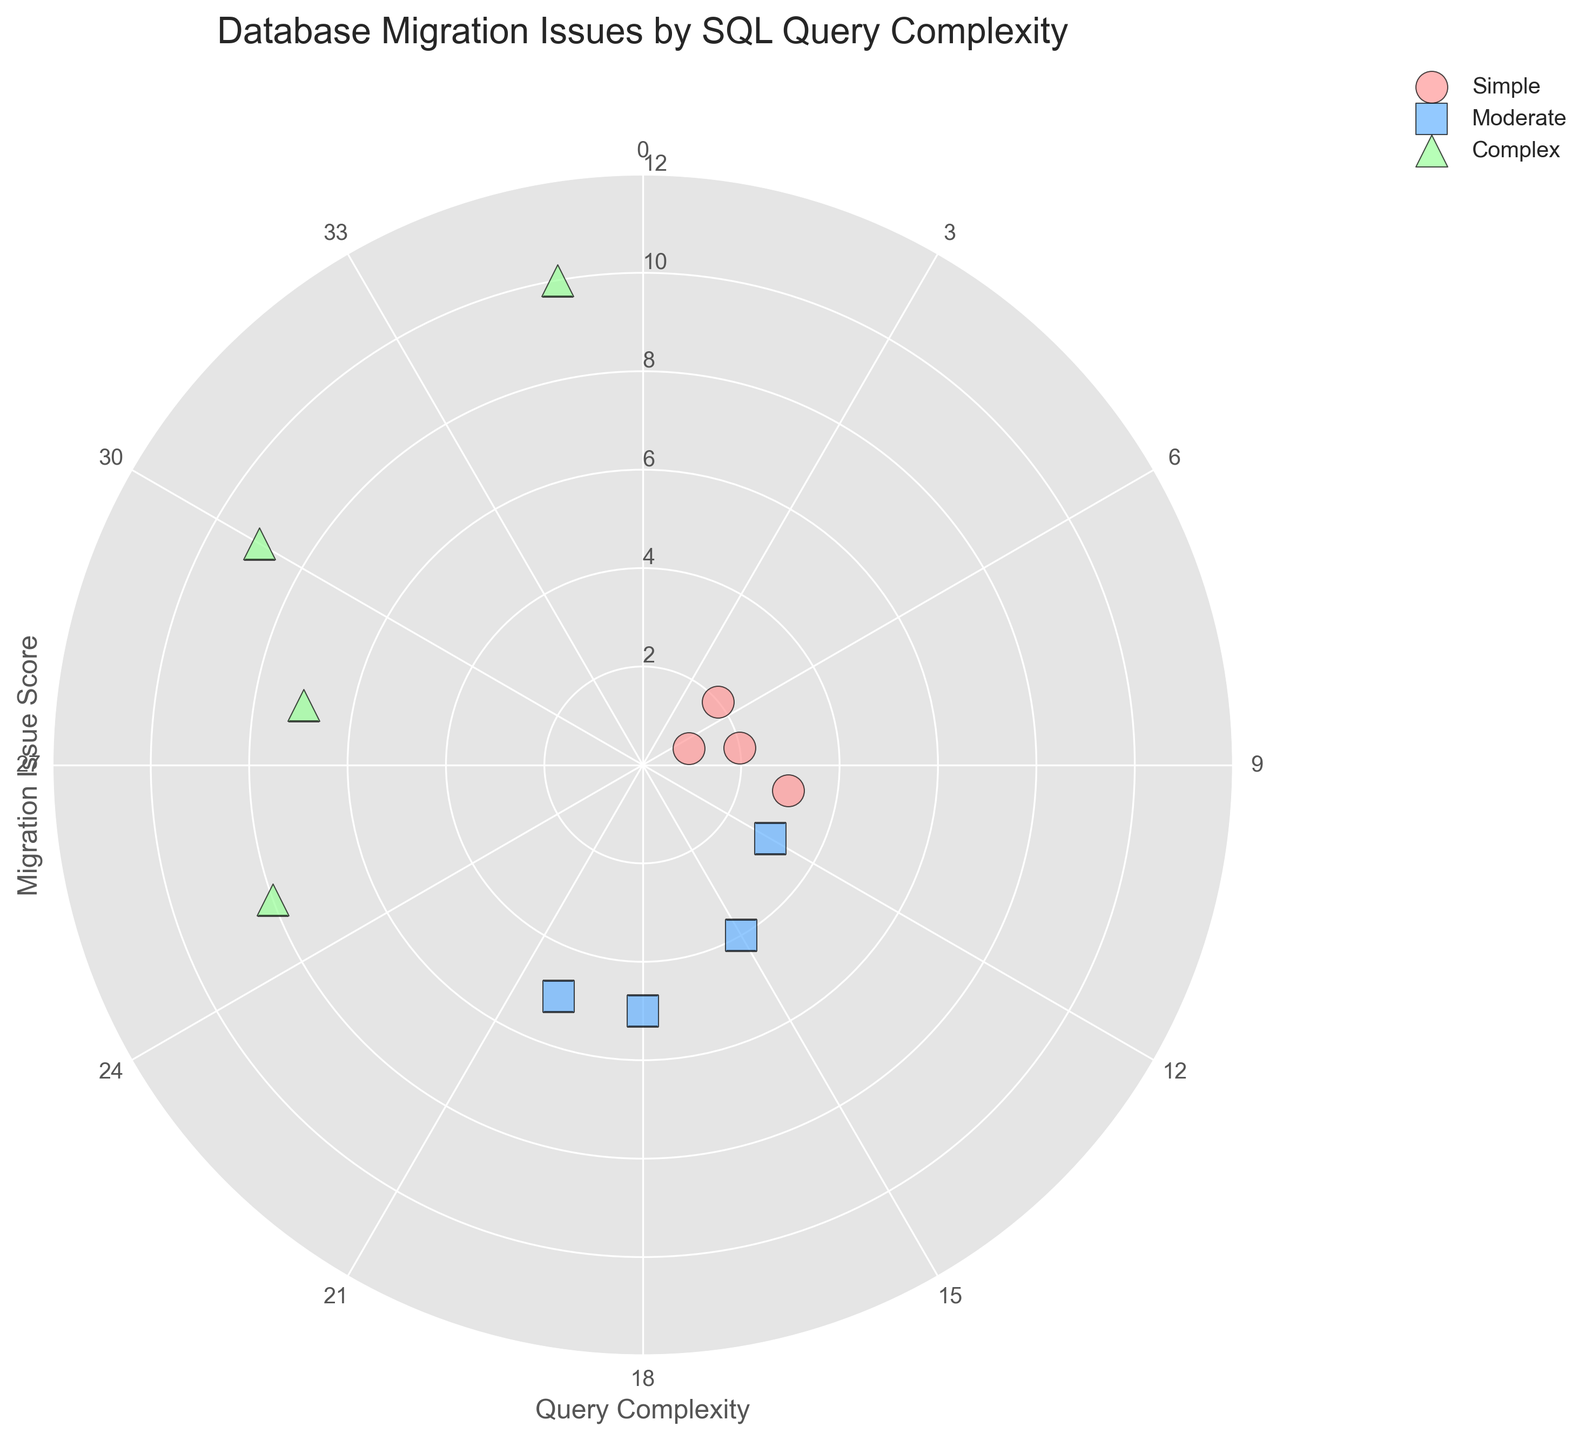What's the title of the figure? The title of the figure is provided in the plot itself, found at the top center. It describes what the figure is about.
Answer: Database Migration Issues by SQL Query Complexity How many 'Complex' category data points are there on the chart? To find the number of 'Complex' category data points, look at the scattered points that use the color and marker corresponding to 'Complex' (green triangles). There are four such data points.
Answer: Four Which category has the highest Migration Issue Score and what is the score? Identify the data point with the highest radial distance (y-axis) and check its category, color, and marker. The highest Migration Issue Score is 10, from the 'Complex' category.
Answer: Complex, 10 What is the average Migration Issue Score for 'Moderate' category queries? Identify the 'Moderate' category data points (blue squares), note their Migration Issue Scores, sum them up and divide by the number of points. Scores: 4, 5, 3, 5. The sum is 17, and the average is 17/4.
Answer: 4.25 How do the Migration Issue Scores compare between the 'Simple' and 'Moderate' categories? List the Migration Issue Scores for each category and compare them. 'Simple' scores are 2, 3, 2, 1. 'Moderate' scores are 4, 5, 3, 5. The scores in 'Moderate' are generally higher than those in 'Simple'.
Answer: Moderate category has higher scores Which Query Complexity corresponds to a Migration Issue Score of 3 in the 'Simple' category? Look at the 'Simple' category data points and identify the one with a Migration Issue Score of 3; it corresponds to a Query Complexity of 10.
Answer: 10 What is the total number of data points in the figure? Count the total number of scattered points regardless of the category. We have four 'Simple', four 'Moderate', and four 'Complex' data points. 4 + 4 + 4 = 12.
Answer: 12 How does the range of Migration Issue Scores for 'Complex' queries compare to that of 'Simple' queries? Identify the minimum and maximum Migration Issue Scores for both categories. 'Simple' ranges from 1 to 3, 'Complex' ranges from 7 to 10. The 'Complex' category has a wider range (3) than the 'Simple' category (2).
Answer: Complex category has a wider range What are the labels on the radial ticks? The radial ticks are marked at intervals and labeled to show radial distances. These labels are 2, 4, 6, 8, 10, 12.
Answer: 2, 4, 6, 8, 10, 12 What is the Query Complexity for the data point at the highest radial position on the chart? The highest radial position on the chart is for the data point with a Migration Issue Score of 10. Its Query Complexity is 35, identified from the corresponding angular position (35 degrees).
Answer: 35 